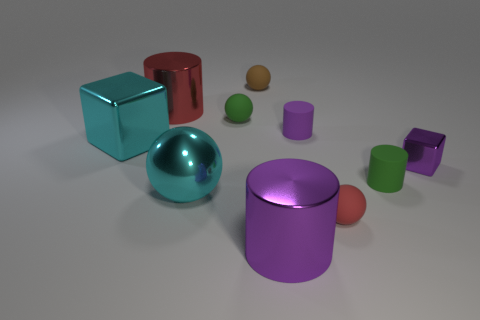Subtract 1 cylinders. How many cylinders are left? 3 Subtract all blue cylinders. Subtract all yellow cubes. How many cylinders are left? 4 Subtract all cylinders. How many objects are left? 6 Subtract 0 brown cylinders. How many objects are left? 10 Subtract all big cyan things. Subtract all large cylinders. How many objects are left? 6 Add 6 small red balls. How many small red balls are left? 7 Add 5 large red rubber blocks. How many large red rubber blocks exist? 5 